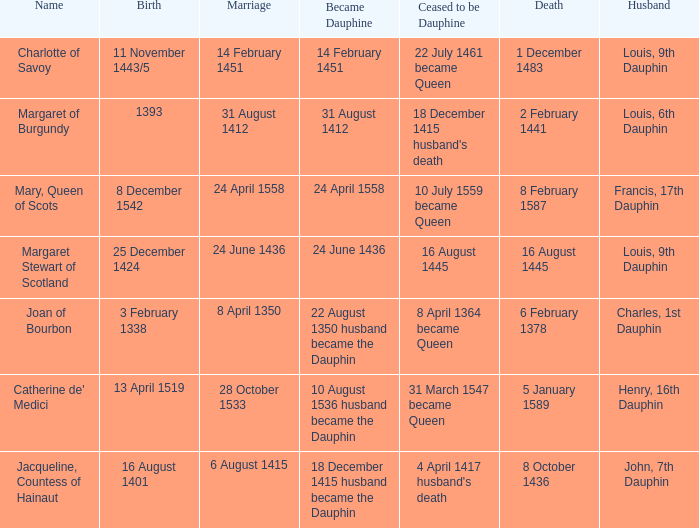When was the marriage when became dauphine is 31 august 1412? 31 August 1412. 